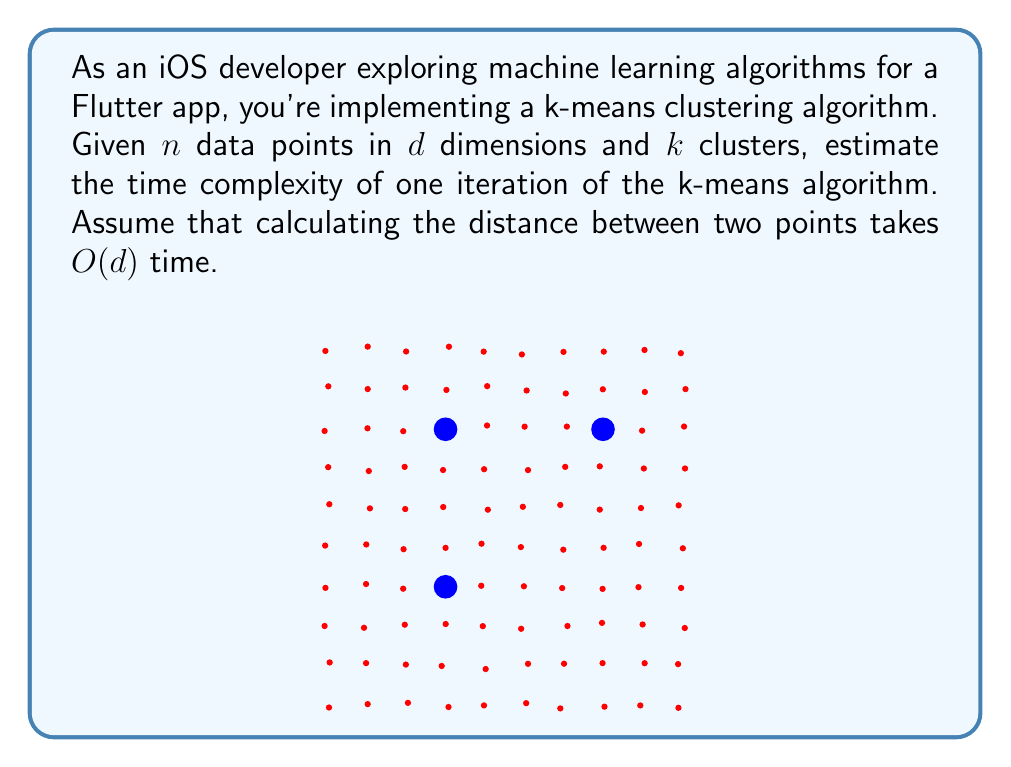Provide a solution to this math problem. Let's break down the k-means algorithm steps and analyze their time complexity:

1. Assign each point to the nearest centroid:
   - For each of the $n$ points, we need to calculate the distance to all $k$ centroids.
   - Calculating distance between two points in $d$ dimensions takes $O(d)$ time.
   - For each point, we perform $k$ distance calculations and find the minimum.
   - Time for this step: $O(nkd)$

2. Recalculate centroids:
   - For each of the $k$ clusters, we sum up all points assigned to it and divide by the number of points.
   - In the worst case, all $n$ points could be in one cluster, so we need to consider $n$ points for each centroid.
   - Summing $d$ dimensions for $n$ points takes $O(nd)$ time.
   - We do this for $k$ centroids.
   - Time for this step: $O(knd)$

3. Combining the steps:
   The total time for one iteration is the sum of these two steps:
   $O(nkd) + O(knd) = O(nkd)$

Therefore, the time complexity of one iteration of the k-means algorithm for $n$ data points in $d$ dimensions with $k$ clusters is $O(nkd)$.
Answer: $O(nkd)$ 